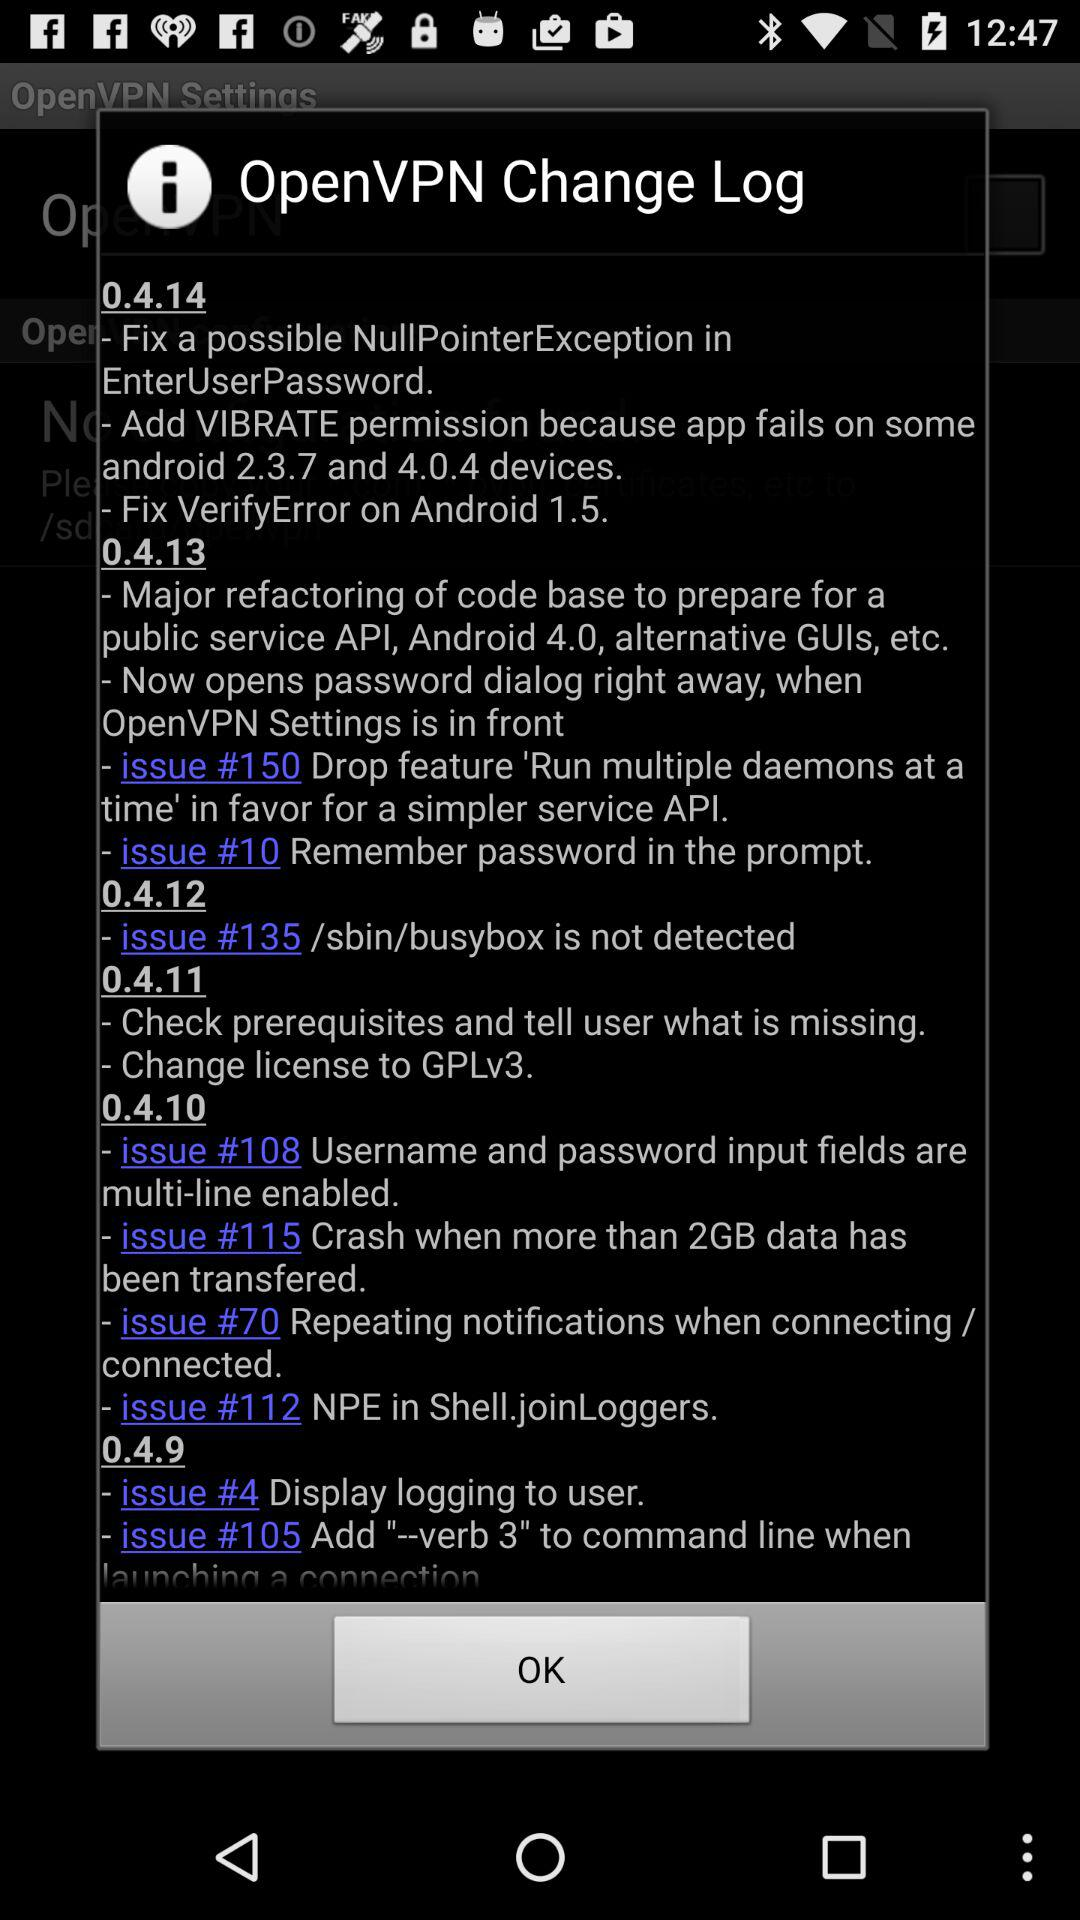What are the updates in version 0.4.14? The updates in version 0.4.14 are "Fix a possible NullPointerException in EnterUserPassword", "Add VIBRATE permission because app fails on some android 2.3.7 and 4.0.4 devices" and "Fix VerifyError on Android 1.5". 